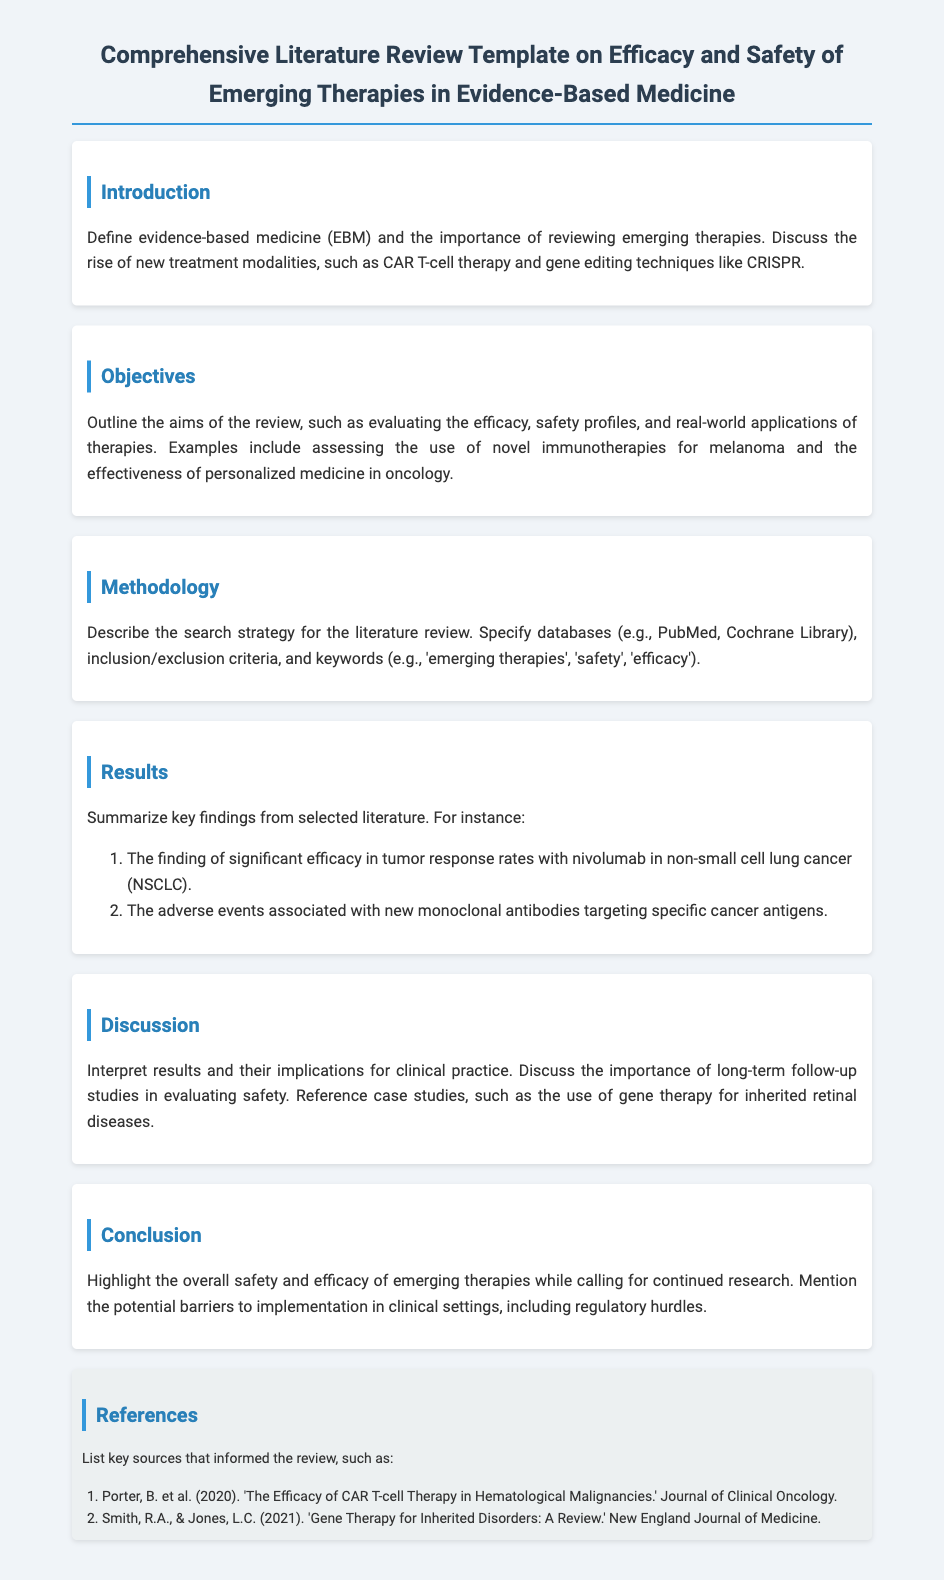What is the main focus of the literature review? The literature review focuses on the efficacy and safety of emerging therapies in evidence-based medicine.
Answer: efficacy and safety of emerging therapies in evidence-based medicine What is one example of a new treatment modality mentioned? The document mentions CAR T-cell therapy as a new treatment modality.
Answer: CAR T-cell therapy Which databases are specified for the literature search? The literature review specifies databases such as PubMed and Cochrane Library for the search strategy.
Answer: PubMed, Cochrane Library What significant finding is highlighted regarding nivolumab? The review highlights significant efficacy in tumor response rates with nivolumab in non-small cell lung cancer.
Answer: significant efficacy in tumor response rates with nivolumab in non-small cell lung cancer What is a potential barrier to implementation mentioned? Regulatory hurdles are mentioned as potential barriers to the implementation of emerging therapies.
Answer: regulatory hurdles What is the overall conclusion about emerging therapies? The conclusion highlights the overall safety and efficacy of emerging therapies while calling for continued research.
Answer: overall safety and efficacy of emerging therapies Which case study is referenced in the discussion? The case study referenced in the discussion is the use of gene therapy for inherited retinal diseases.
Answer: gene therapy for inherited retinal diseases What are the aims of the review? The aims include evaluating efficacy, safety profiles, and real-world applications of therapies.
Answer: evaluating efficacy, safety profiles, and real-world applications of therapies 